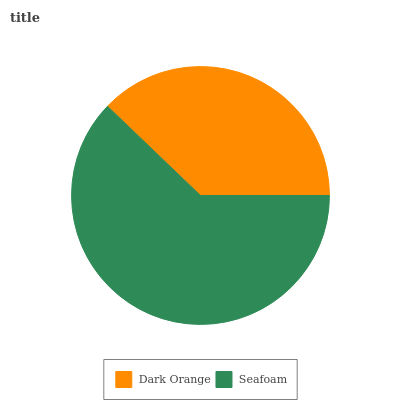Is Dark Orange the minimum?
Answer yes or no. Yes. Is Seafoam the maximum?
Answer yes or no. Yes. Is Seafoam the minimum?
Answer yes or no. No. Is Seafoam greater than Dark Orange?
Answer yes or no. Yes. Is Dark Orange less than Seafoam?
Answer yes or no. Yes. Is Dark Orange greater than Seafoam?
Answer yes or no. No. Is Seafoam less than Dark Orange?
Answer yes or no. No. Is Seafoam the high median?
Answer yes or no. Yes. Is Dark Orange the low median?
Answer yes or no. Yes. Is Dark Orange the high median?
Answer yes or no. No. Is Seafoam the low median?
Answer yes or no. No. 